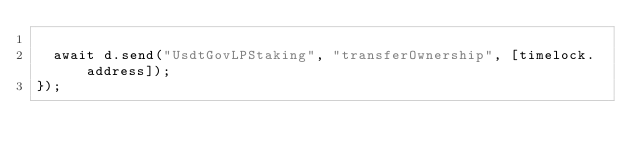<code> <loc_0><loc_0><loc_500><loc_500><_JavaScript_>
  await d.send("UsdtGovLPStaking", "transferOwnership", [timelock.address]);
});
</code> 